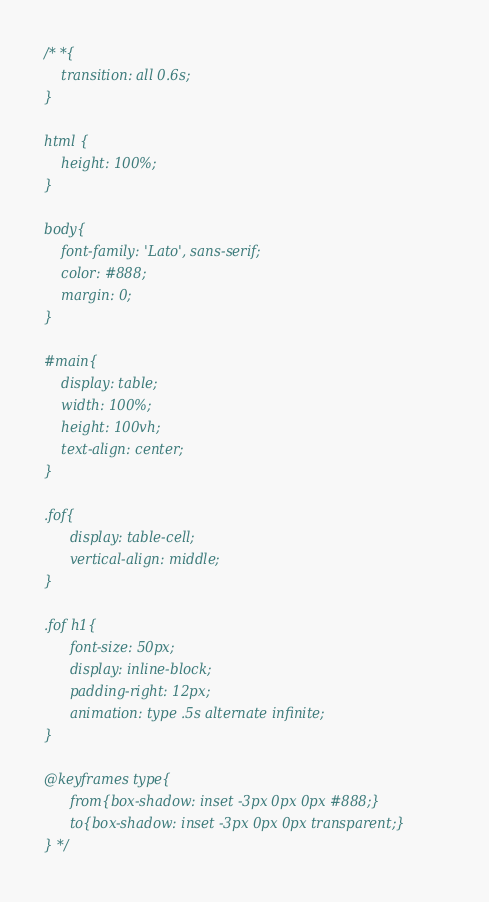<code> <loc_0><loc_0><loc_500><loc_500><_CSS_>/* *{
    transition: all 0.6s;
}

html {
    height: 100%;
}

body{
    font-family: 'Lato', sans-serif;
    color: #888;
    margin: 0;
}

#main{
    display: table;
    width: 100%;
    height: 100vh;
    text-align: center;
}

.fof{
	  display: table-cell;
	  vertical-align: middle;
}

.fof h1{
	  font-size: 50px;
	  display: inline-block;
	  padding-right: 12px;
	  animation: type .5s alternate infinite;
}

@keyframes type{
	  from{box-shadow: inset -3px 0px 0px #888;}
	  to{box-shadow: inset -3px 0px 0px transparent;}
} */
</code> 